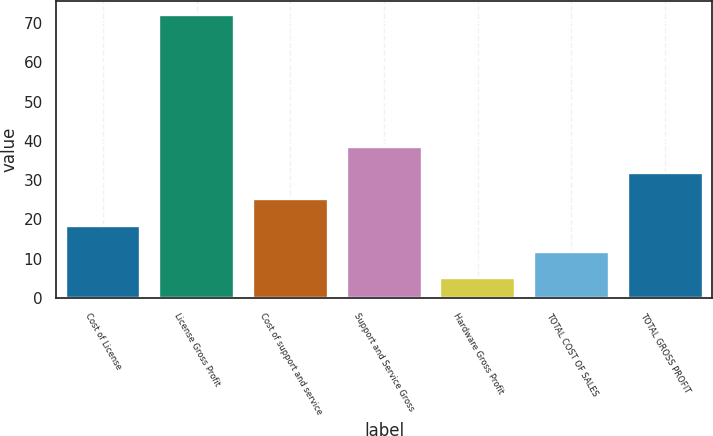<chart> <loc_0><loc_0><loc_500><loc_500><bar_chart><fcel>Cost of License<fcel>License Gross Profit<fcel>Cost of support and service<fcel>Support and Service Gross<fcel>Hardware Gross Profit<fcel>TOTAL COST OF SALES<fcel>TOTAL GROSS PROFIT<nl><fcel>18.4<fcel>72<fcel>25.1<fcel>38.5<fcel>5<fcel>11.7<fcel>31.8<nl></chart> 